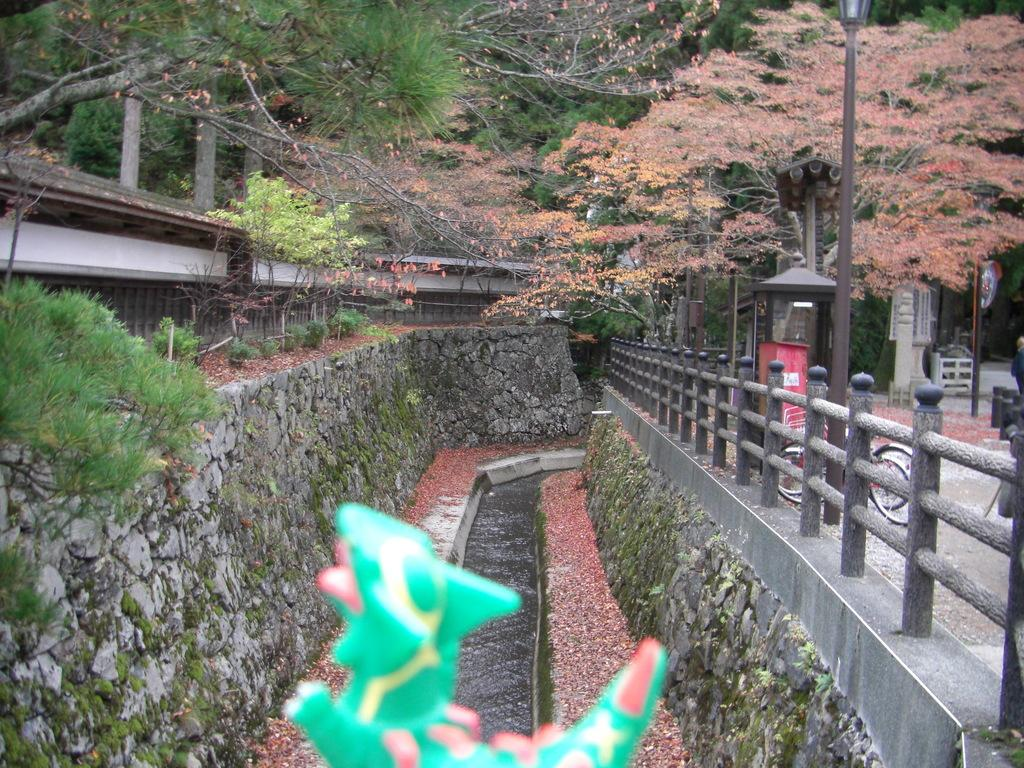What type of structure can be seen in the image? There is a bridge in the image. What mode of transportation is visible in the image? There is a bicycle in the image. What are the tall, thin objects in the image? There are poles in the image. What are the small, raised platforms in the image? There are stands in the image. What type of vegetation is present in the image? There are trees in the image. What type of small buildings are in the image? There are sheds in the image. What object is located at the front of the image? There is a toy in the front of the image. What body of water is at the bottom of the image? There is a pond at the bottom of the image. Where is the wilderness located in the image? There is no wilderness present in the image. What type of appliance can be seen in the image? There are no appliances present in the image. 